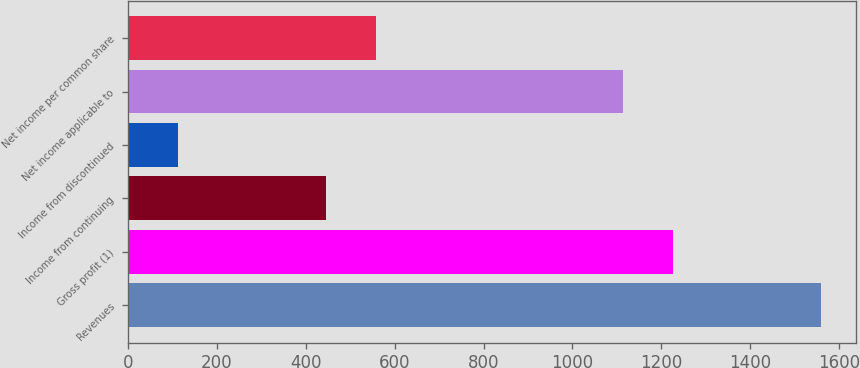Convert chart to OTSL. <chart><loc_0><loc_0><loc_500><loc_500><bar_chart><fcel>Revenues<fcel>Gross profit (1)<fcel>Income from continuing<fcel>Income from discontinued<fcel>Net income applicable to<fcel>Net income per common share<nl><fcel>1559.62<fcel>1225.42<fcel>445.62<fcel>111.42<fcel>1114.02<fcel>557.02<nl></chart> 